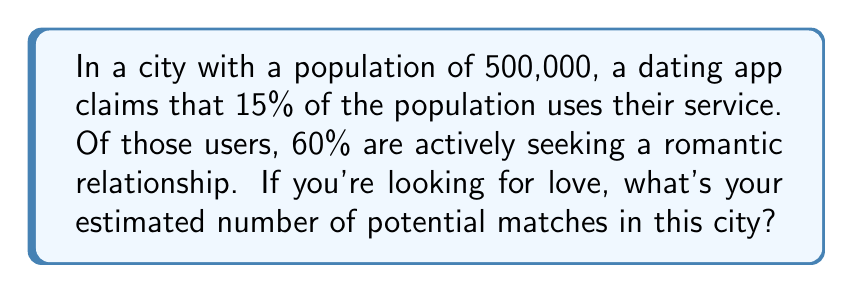Provide a solution to this math problem. Let's break this down step-by-step:

1. Calculate the number of app users:
   $500,000 \times 15\% = 500,000 \times 0.15 = 75,000$ users

2. Calculate the number of active users seeking a relationship:
   $75,000 \times 60\% = 75,000 \times 0.60 = 45,000$ active users

3. This number represents your potential matches. However, it's important to note that this is an estimate and doesn't account for factors like age range, preferences, or compatibility.

The calculation can be summarized as:

$$\text{Potential Matches} = \text{Total Population} \times \text{App Usage \%} \times \text{Active Seekers \%}$$

$$\text{Potential Matches} = 500,000 \times 0.15 \times 0.60 = 45,000$$
Answer: 45,000 potential matches 